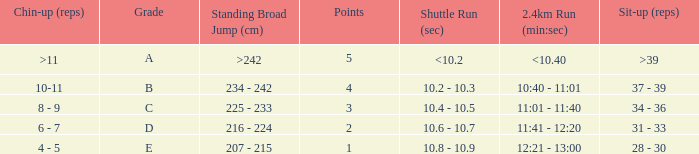Tell me the 2.4km run for points less than 2 12:21 - 13:00. 